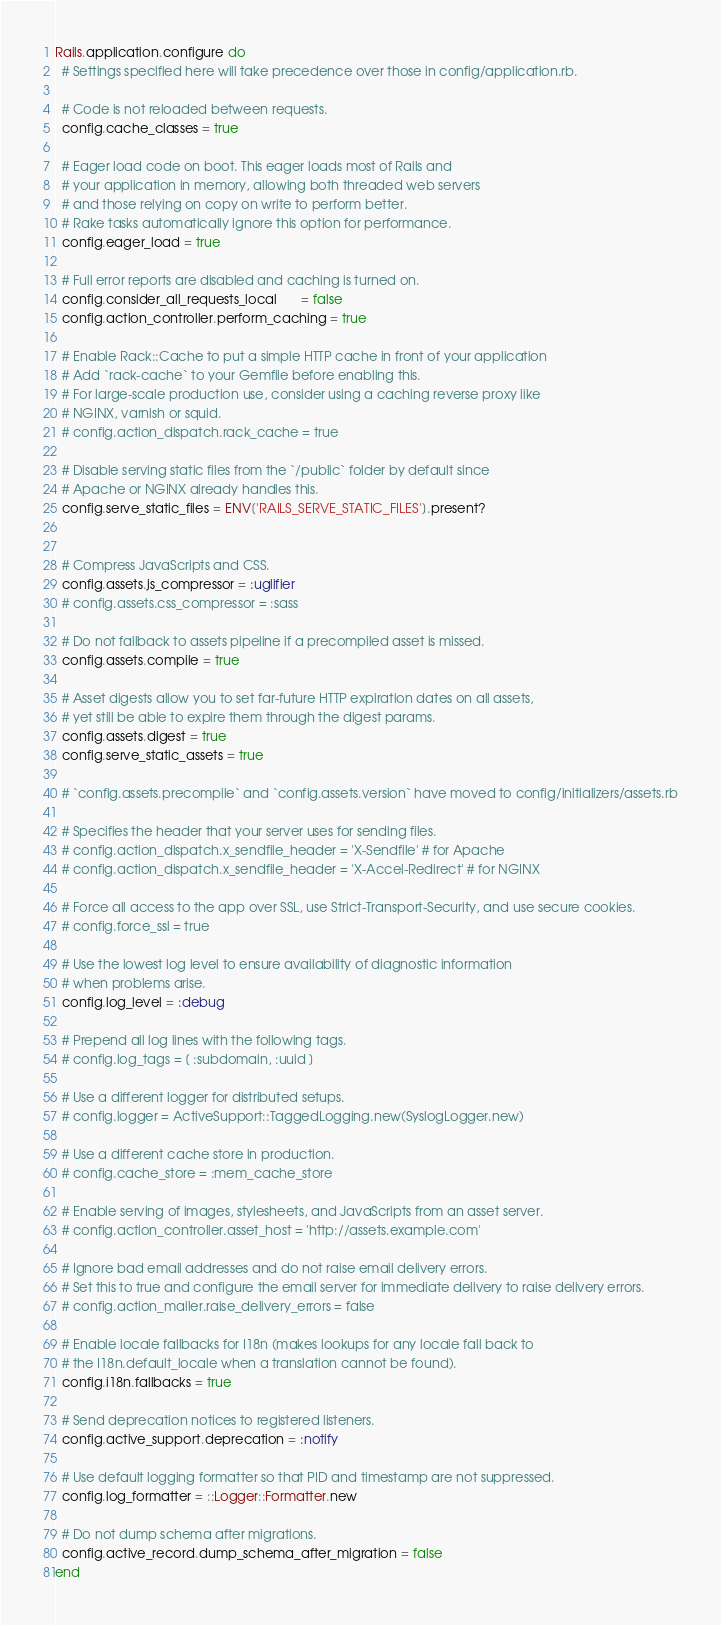<code> <loc_0><loc_0><loc_500><loc_500><_Ruby_>Rails.application.configure do
  # Settings specified here will take precedence over those in config/application.rb.

  # Code is not reloaded between requests.
  config.cache_classes = true

  # Eager load code on boot. This eager loads most of Rails and
  # your application in memory, allowing both threaded web servers
  # and those relying on copy on write to perform better.
  # Rake tasks automatically ignore this option for performance.
  config.eager_load = true

  # Full error reports are disabled and caching is turned on.
  config.consider_all_requests_local       = false
  config.action_controller.perform_caching = true

  # Enable Rack::Cache to put a simple HTTP cache in front of your application
  # Add `rack-cache` to your Gemfile before enabling this.
  # For large-scale production use, consider using a caching reverse proxy like
  # NGINX, varnish or squid.
  # config.action_dispatch.rack_cache = true

  # Disable serving static files from the `/public` folder by default since
  # Apache or NGINX already handles this.
  config.serve_static_files = ENV['RAILS_SERVE_STATIC_FILES'].present?


  # Compress JavaScripts and CSS.
  config.assets.js_compressor = :uglifier
  # config.assets.css_compressor = :sass

  # Do not fallback to assets pipeline if a precompiled asset is missed.
  config.assets.compile = true

  # Asset digests allow you to set far-future HTTP expiration dates on all assets,
  # yet still be able to expire them through the digest params.
  config.assets.digest = true
  config.serve_static_assets = true

  # `config.assets.precompile` and `config.assets.version` have moved to config/initializers/assets.rb

  # Specifies the header that your server uses for sending files.
  # config.action_dispatch.x_sendfile_header = 'X-Sendfile' # for Apache
  # config.action_dispatch.x_sendfile_header = 'X-Accel-Redirect' # for NGINX

  # Force all access to the app over SSL, use Strict-Transport-Security, and use secure cookies.
  # config.force_ssl = true

  # Use the lowest log level to ensure availability of diagnostic information
  # when problems arise.
  config.log_level = :debug

  # Prepend all log lines with the following tags.
  # config.log_tags = [ :subdomain, :uuid ]

  # Use a different logger for distributed setups.
  # config.logger = ActiveSupport::TaggedLogging.new(SyslogLogger.new)

  # Use a different cache store in production.
  # config.cache_store = :mem_cache_store

  # Enable serving of images, stylesheets, and JavaScripts from an asset server.
  # config.action_controller.asset_host = 'http://assets.example.com'

  # Ignore bad email addresses and do not raise email delivery errors.
  # Set this to true and configure the email server for immediate delivery to raise delivery errors.
  # config.action_mailer.raise_delivery_errors = false

  # Enable locale fallbacks for I18n (makes lookups for any locale fall back to
  # the I18n.default_locale when a translation cannot be found).
  config.i18n.fallbacks = true

  # Send deprecation notices to registered listeners.
  config.active_support.deprecation = :notify

  # Use default logging formatter so that PID and timestamp are not suppressed.
  config.log_formatter = ::Logger::Formatter.new

  # Do not dump schema after migrations.
  config.active_record.dump_schema_after_migration = false
end
</code> 